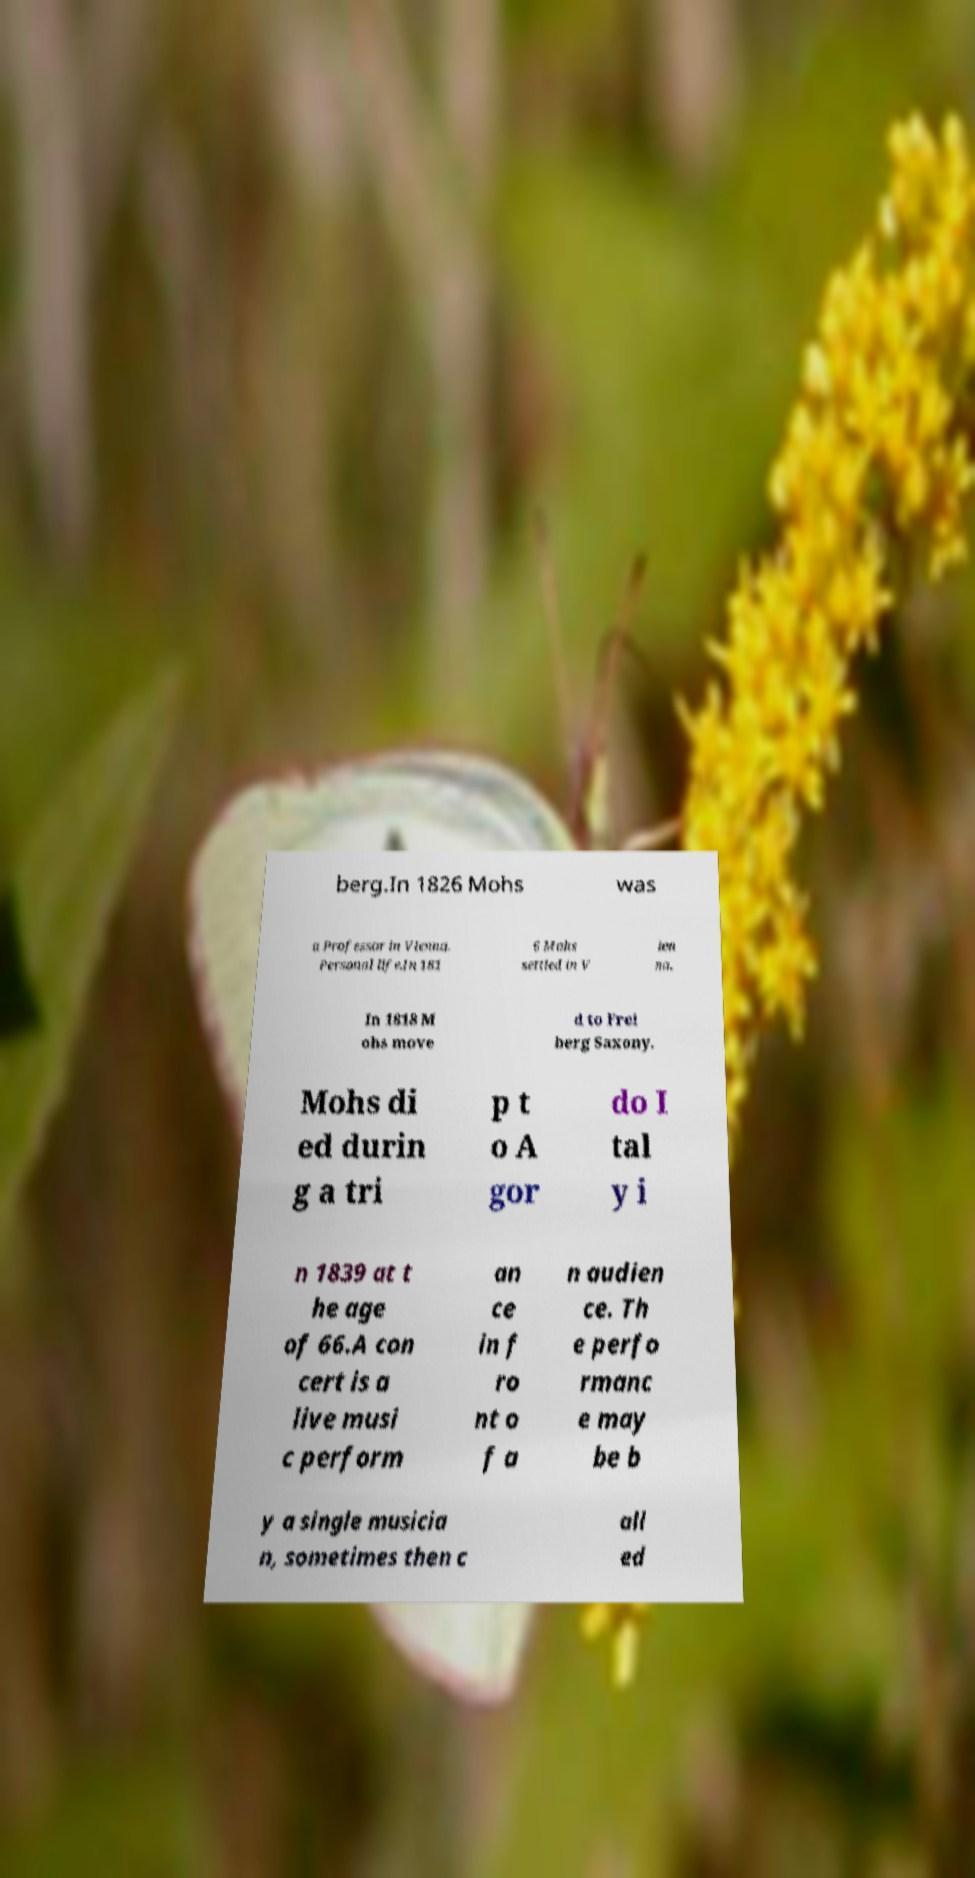There's text embedded in this image that I need extracted. Can you transcribe it verbatim? berg.In 1826 Mohs was a Professor in Vienna. Personal life.In 181 6 Mohs settled in V ien na. In 1818 M ohs move d to Frei berg Saxony. Mohs di ed durin g a tri p t o A gor do I tal y i n 1839 at t he age of 66.A con cert is a live musi c perform an ce in f ro nt o f a n audien ce. Th e perfo rmanc e may be b y a single musicia n, sometimes then c all ed 